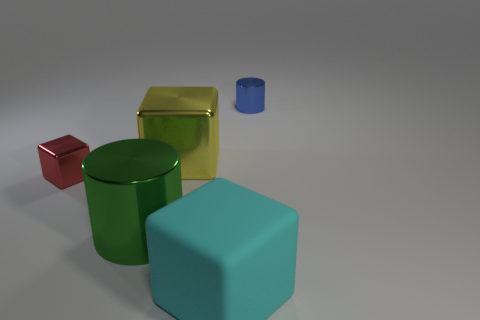Is the size of the rubber block the same as the red shiny thing?
Keep it short and to the point. No. How many cubes are metal objects or big rubber objects?
Offer a very short reply. 3. What number of small blue metal objects are on the right side of the large cube behind the large matte thing?
Your answer should be very brief. 1. Is the shape of the blue object the same as the big yellow thing?
Ensure brevity in your answer.  No. The other red object that is the same shape as the matte thing is what size?
Give a very brief answer. Small. There is a big object behind the small thing on the left side of the big yellow shiny block; what shape is it?
Provide a short and direct response. Cube. The red metallic cube has what size?
Offer a terse response. Small. The big matte thing has what shape?
Provide a succinct answer. Cube. There is a blue metal object; is it the same shape as the large shiny thing behind the small red thing?
Your answer should be compact. No. Does the shiny object that is on the right side of the yellow metallic block have the same shape as the cyan rubber thing?
Ensure brevity in your answer.  No. 